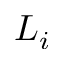Convert formula to latex. <formula><loc_0><loc_0><loc_500><loc_500>L _ { i }</formula> 